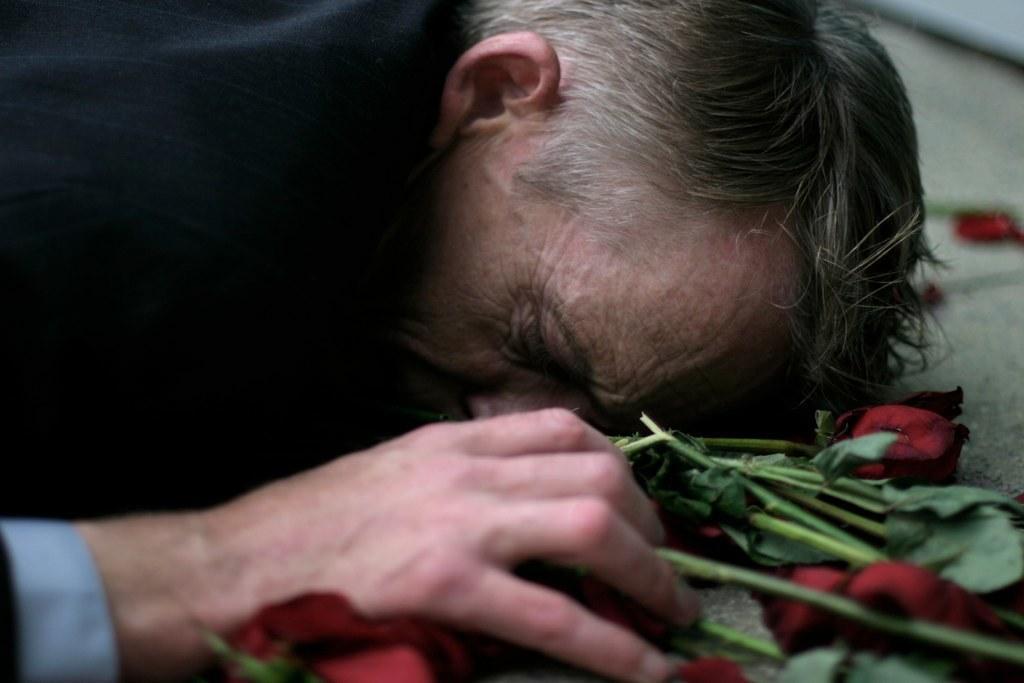Please provide a concise description of this image. In this image there is man laying, beside him there are roses. 